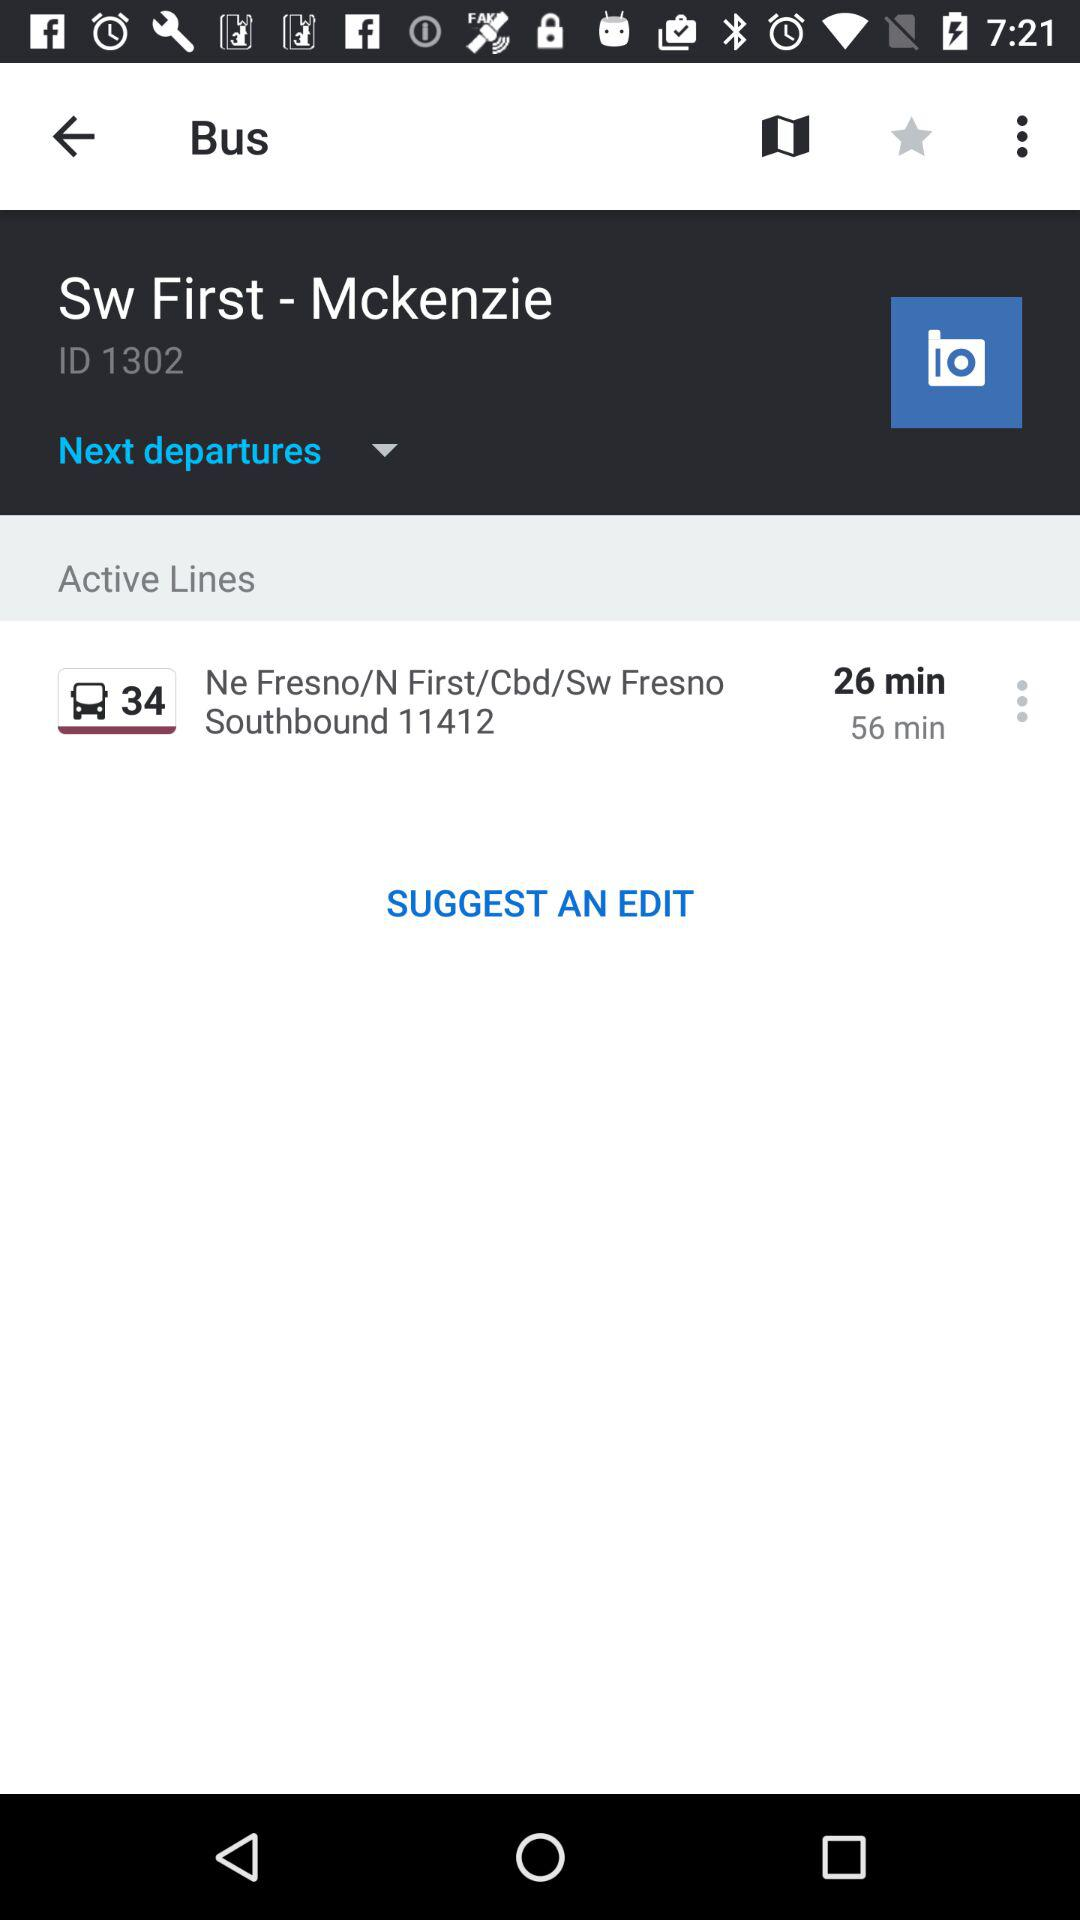Where is it to?
When the provided information is insufficient, respond with <no answer>. <no answer> 